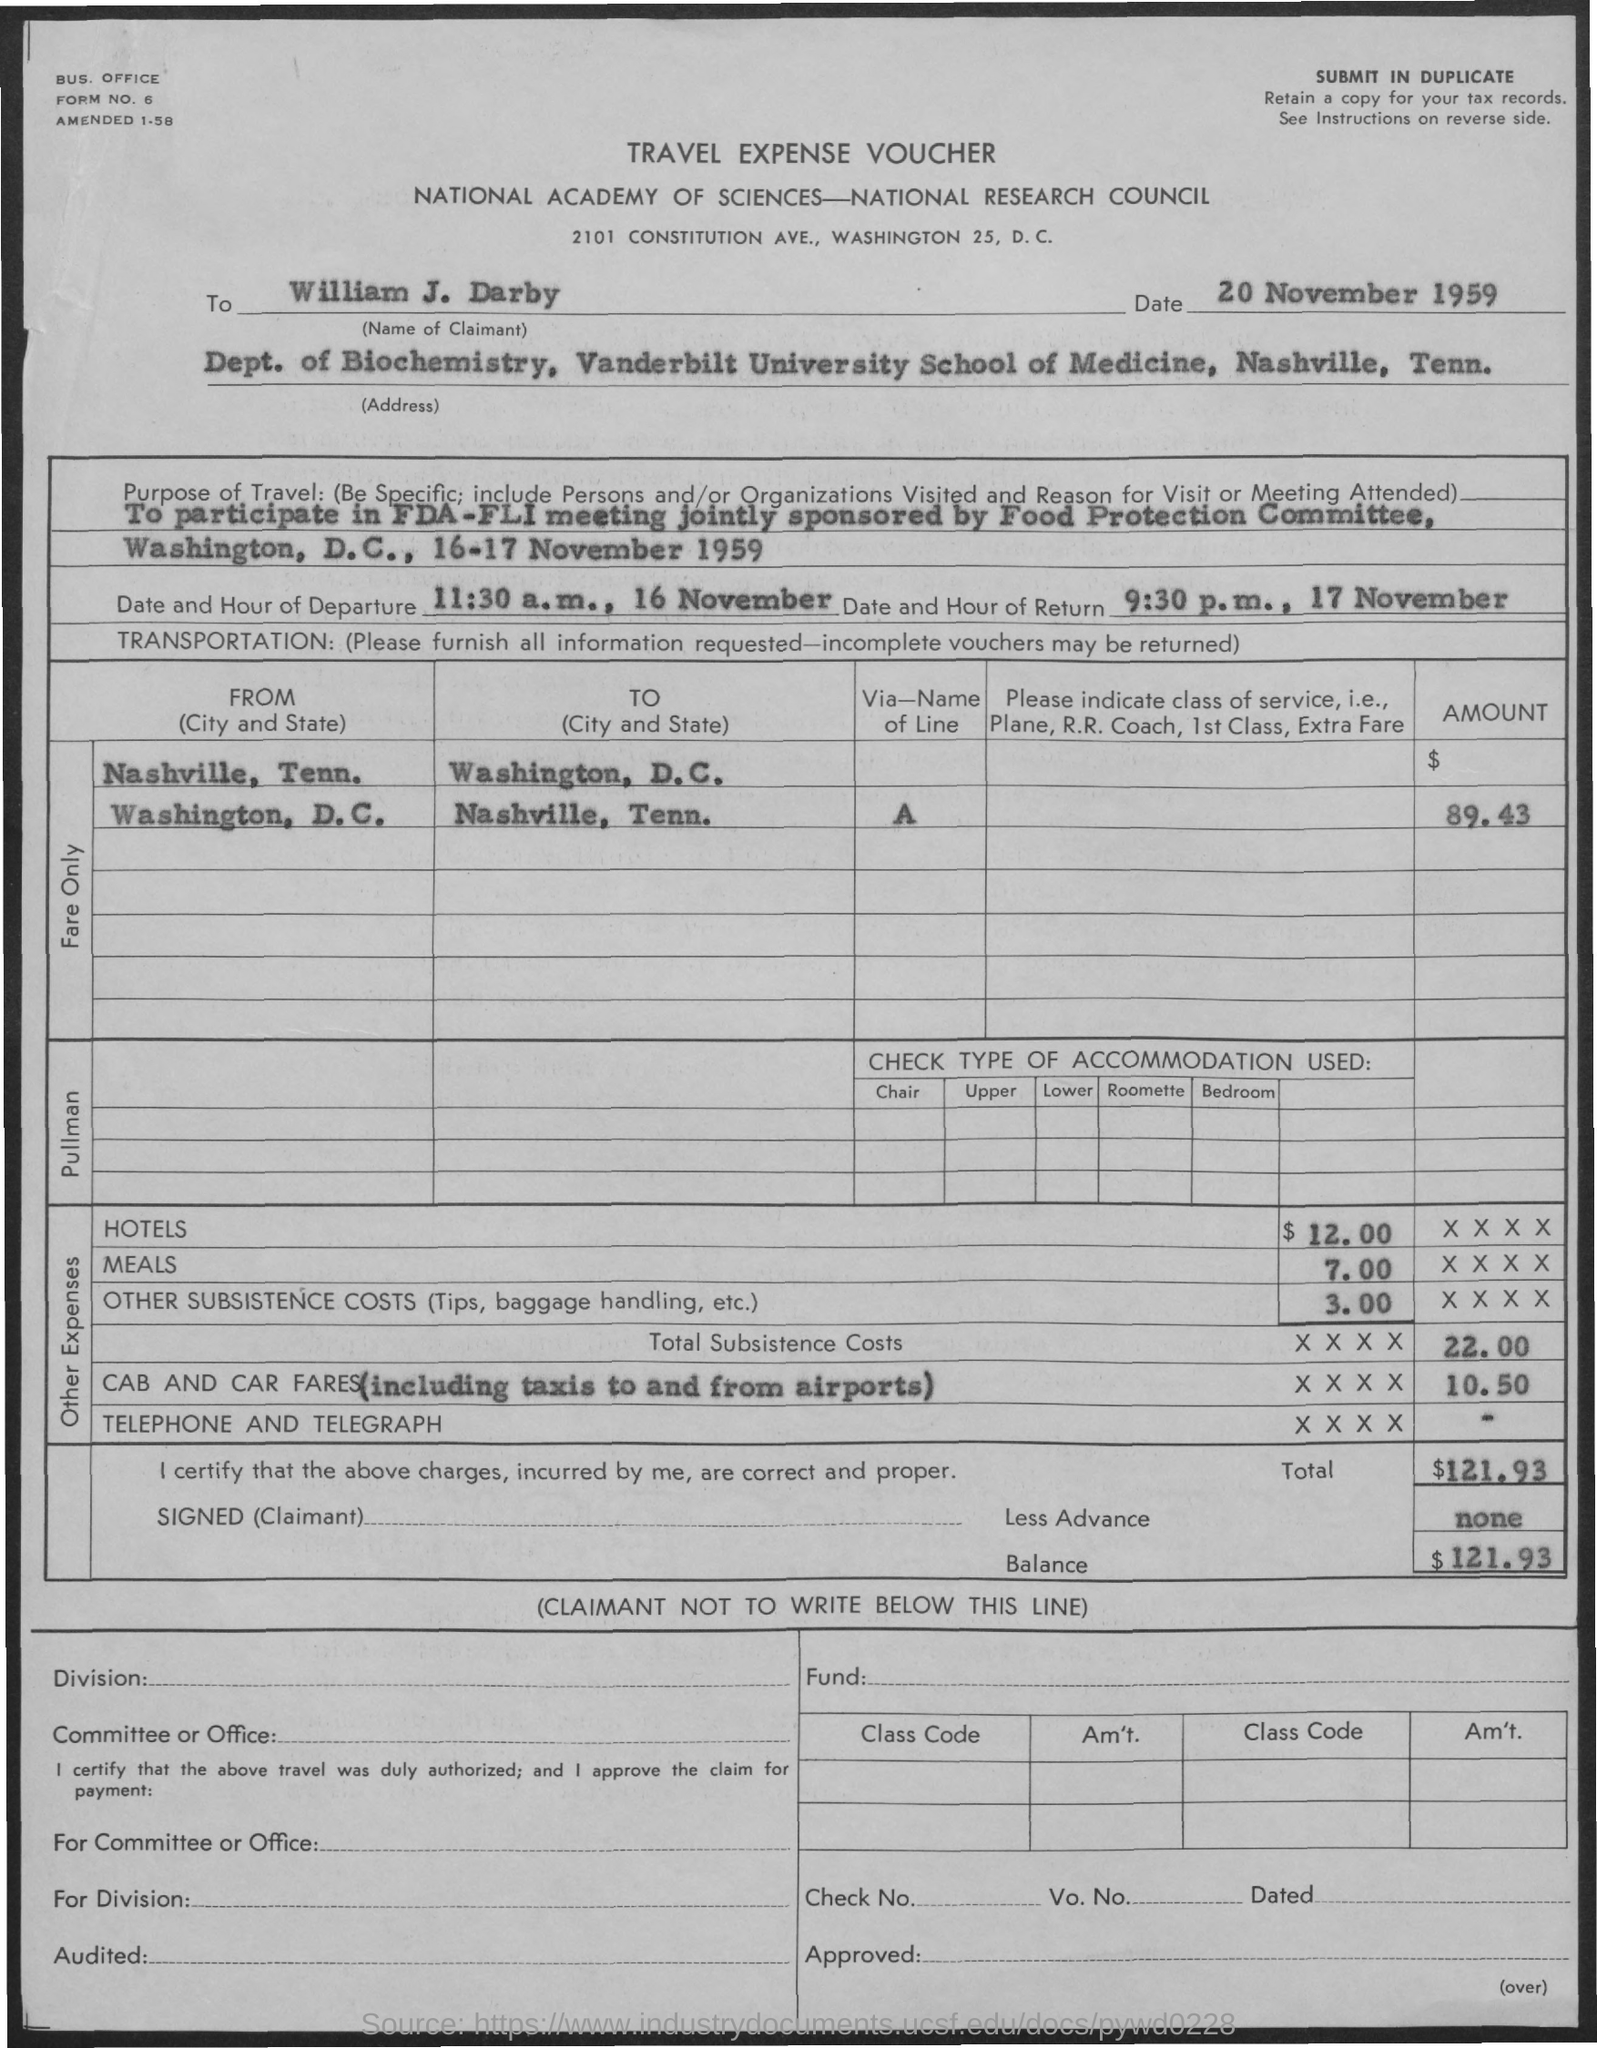Highlight a few significant elements in this photo. The balance amount mentioned in the voucher is $121.93. According to the voucher, the individual is expected to return on November 17th at 9:30 p.m. The date and hour of departure as specified in the voucher are 11:30 a.m. on November 16th. The person named in the voucher is William J. Darby. The travel expense voucher is a type of voucher. 